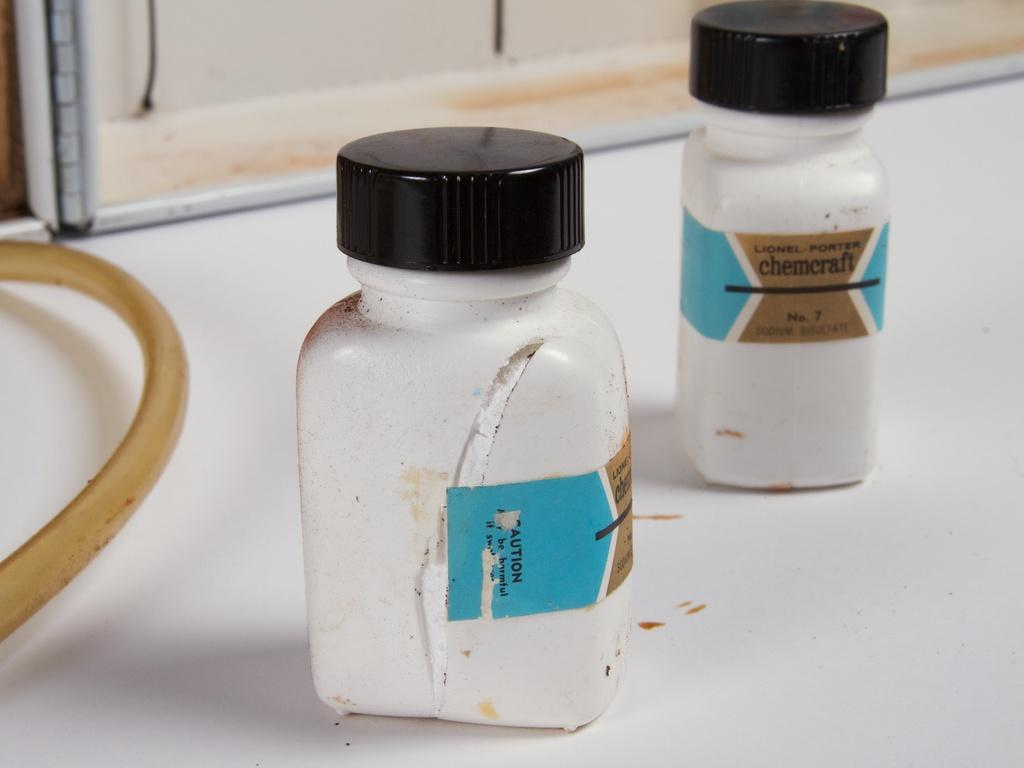<image>
Offer a succinct explanation of the picture presented. Two bottles of chemcraft powder are cut open on a white counter. 